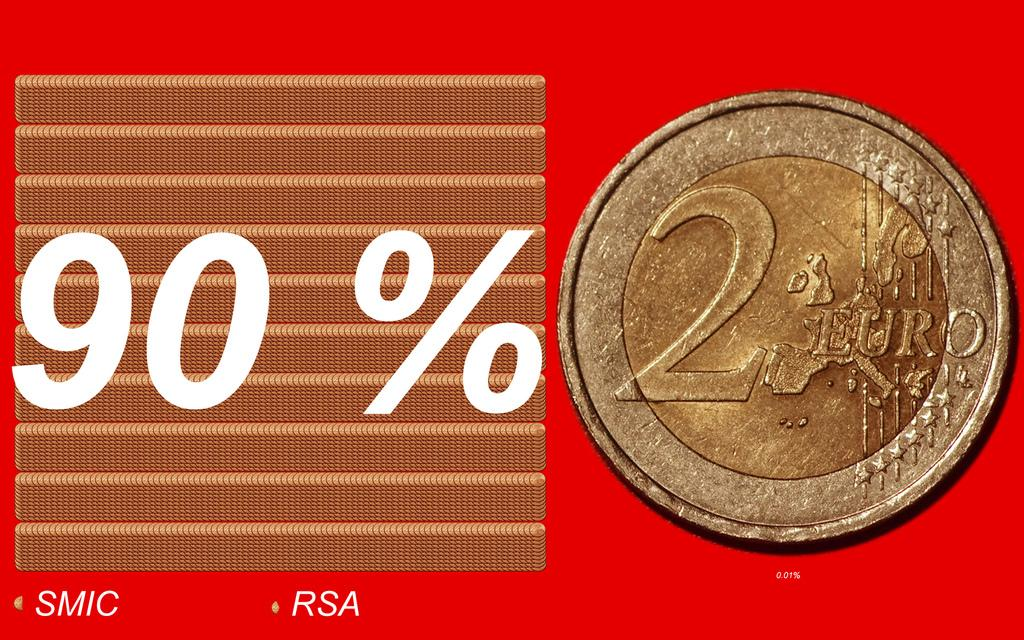<image>
Offer a succinct explanation of the picture presented. A coin valued at 2 euro is next to a chart that says 90% 